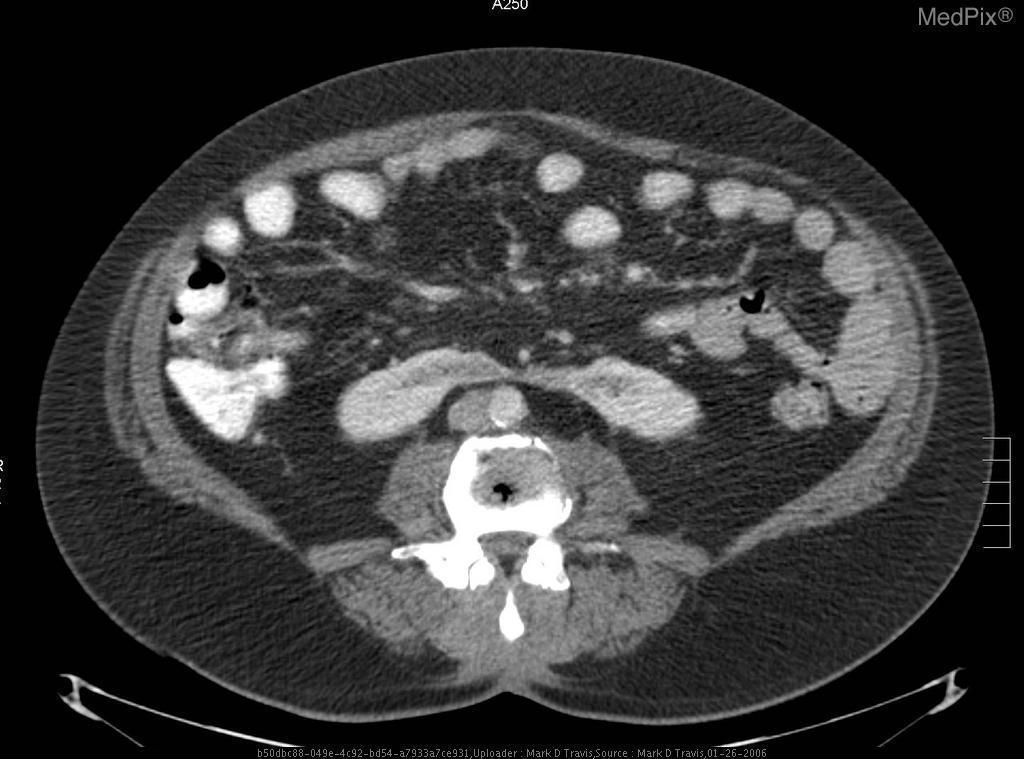Are the kidneys in this image abnormal?
Quick response, please. Yes. What is the organ pictured superior to the aorta?
Keep it brief. Horsehoe kidney. What is above the aorta in this image?
Give a very brief answer. Horsehoe kidney. What are the multiple round hyperdensities located immediately inferior to the musculature?
Write a very short answer. Intestine. What are the anterior circular hyperdensities?
Write a very short answer. Intestine. What material is the peripheral hypodensity?
Short answer required. Fat. What is the the dark gray surrounding the periphery of the image?
Give a very brief answer. Fat. 